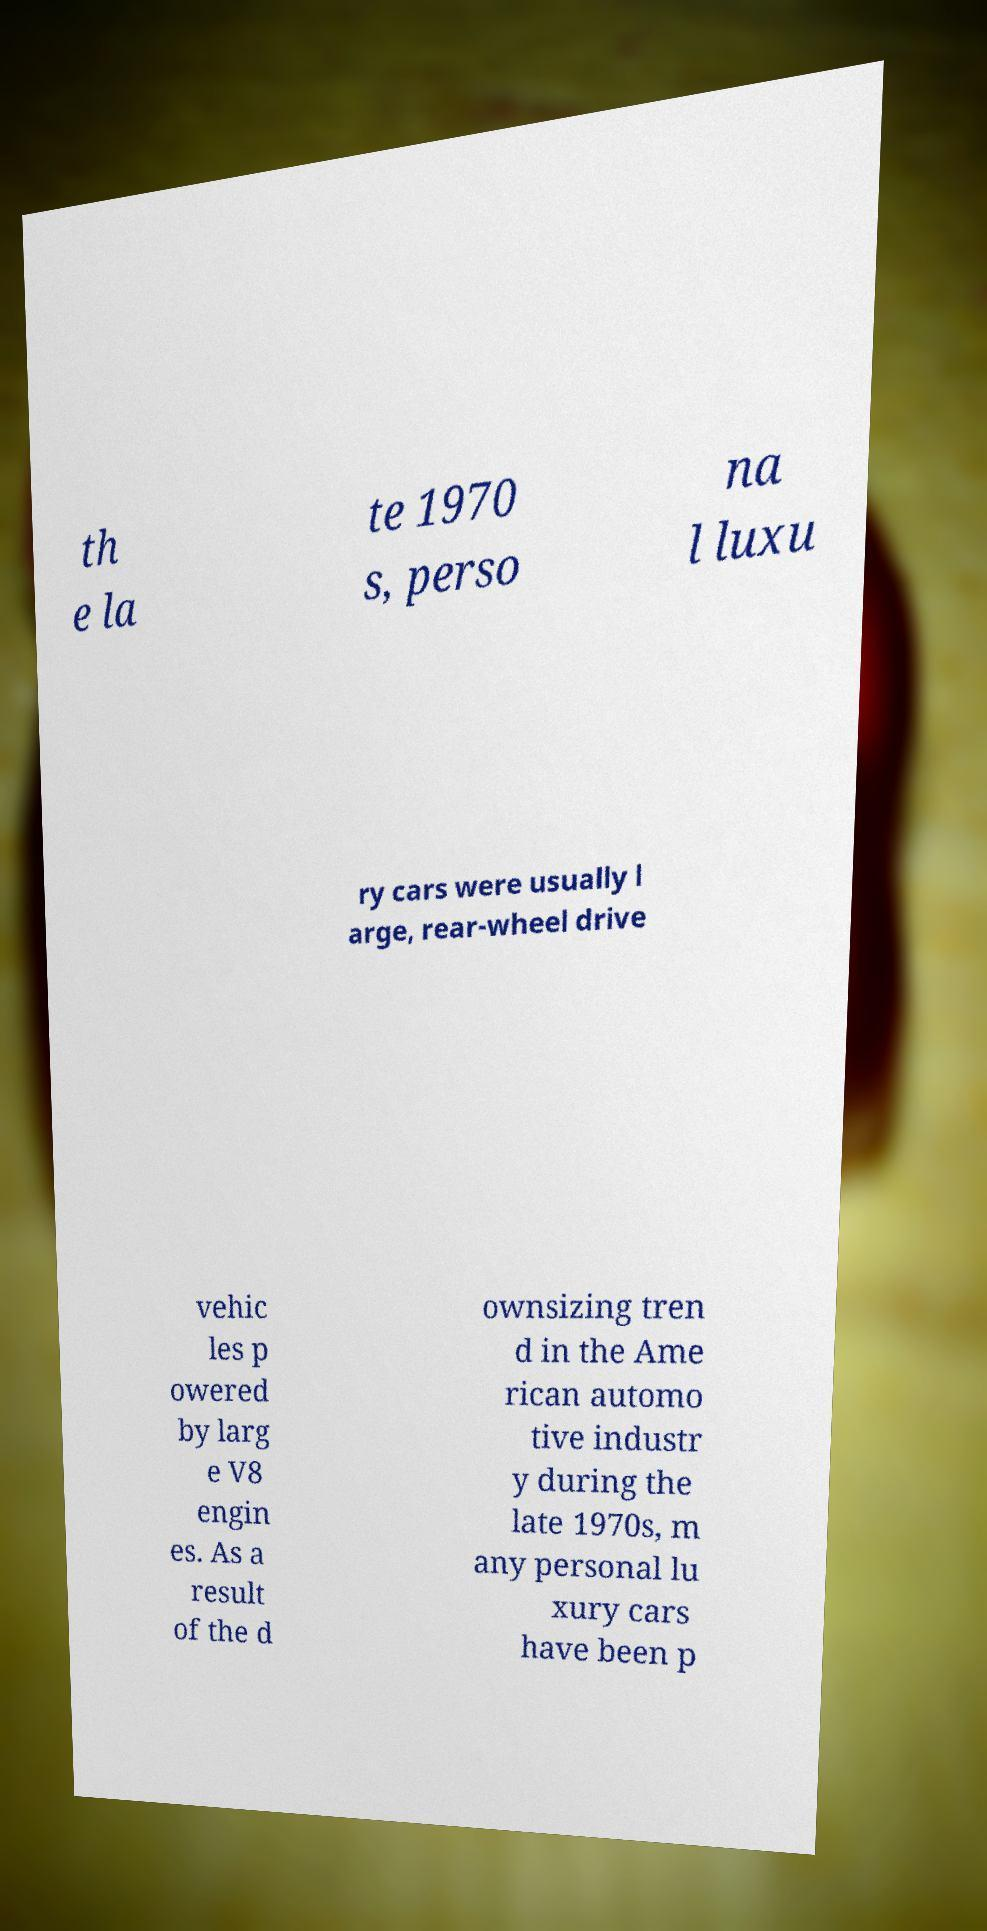For documentation purposes, I need the text within this image transcribed. Could you provide that? th e la te 1970 s, perso na l luxu ry cars were usually l arge, rear-wheel drive vehic les p owered by larg e V8 engin es. As a result of the d ownsizing tren d in the Ame rican automo tive industr y during the late 1970s, m any personal lu xury cars have been p 